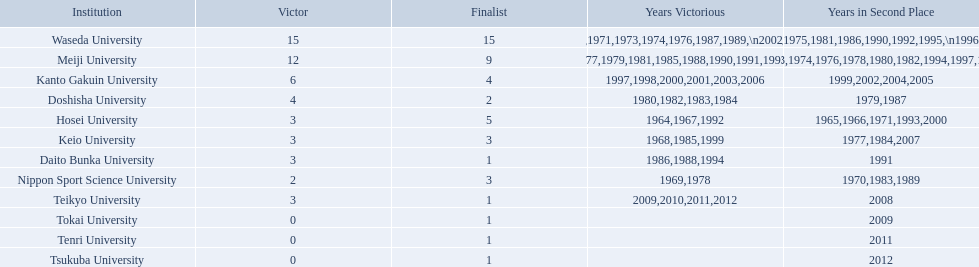What are all of the universities? Waseda University, Meiji University, Kanto Gakuin University, Doshisha University, Hosei University, Keio University, Daito Bunka University, Nippon Sport Science University, Teikyo University, Tokai University, Tenri University, Tsukuba University. And their scores? 15, 12, 6, 4, 3, 3, 3, 2, 3, 0, 0, 0. Which university scored won the most? Waseda University. 